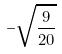<formula> <loc_0><loc_0><loc_500><loc_500>- \sqrt { \frac { 9 } { 2 0 } }</formula> 